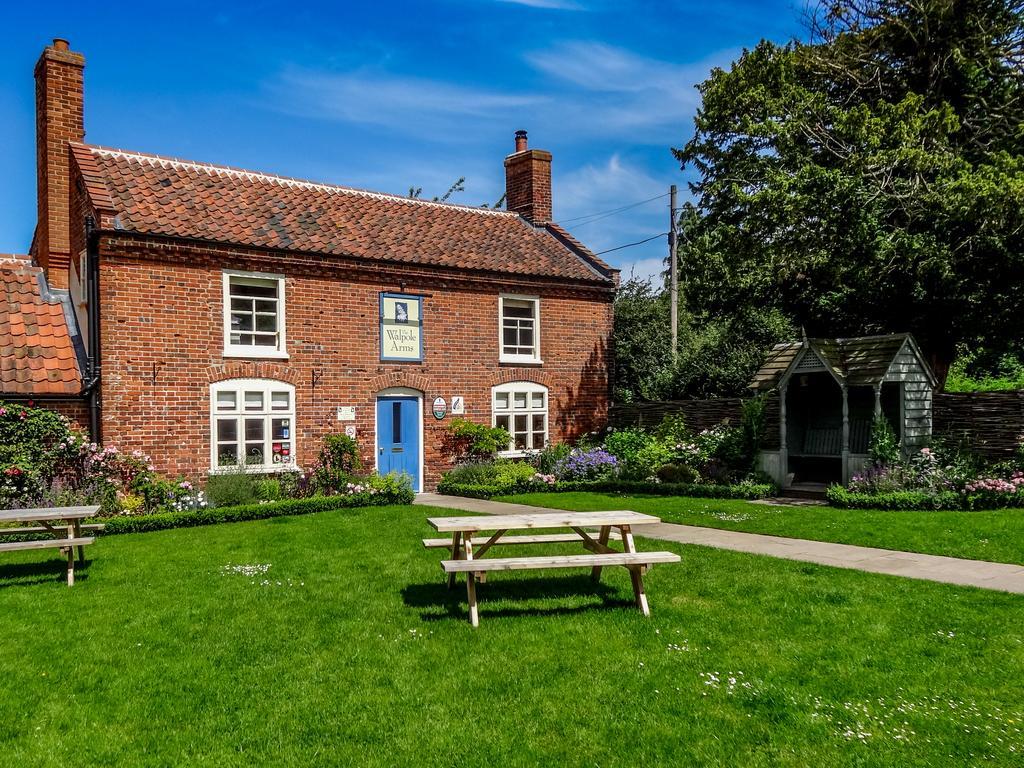Can you describe this image briefly? In the foreground I can see two benches on grass, flowering plants, trees, houses, windows, board and a pole. At the top I can see the blue sky. This image is taken, may be during a day. 